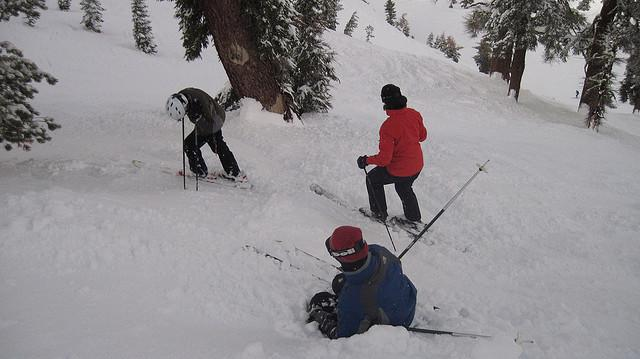How did the person wearing blue come to be in the position they are in? Please explain your reasoning. falling. The person is falling. 